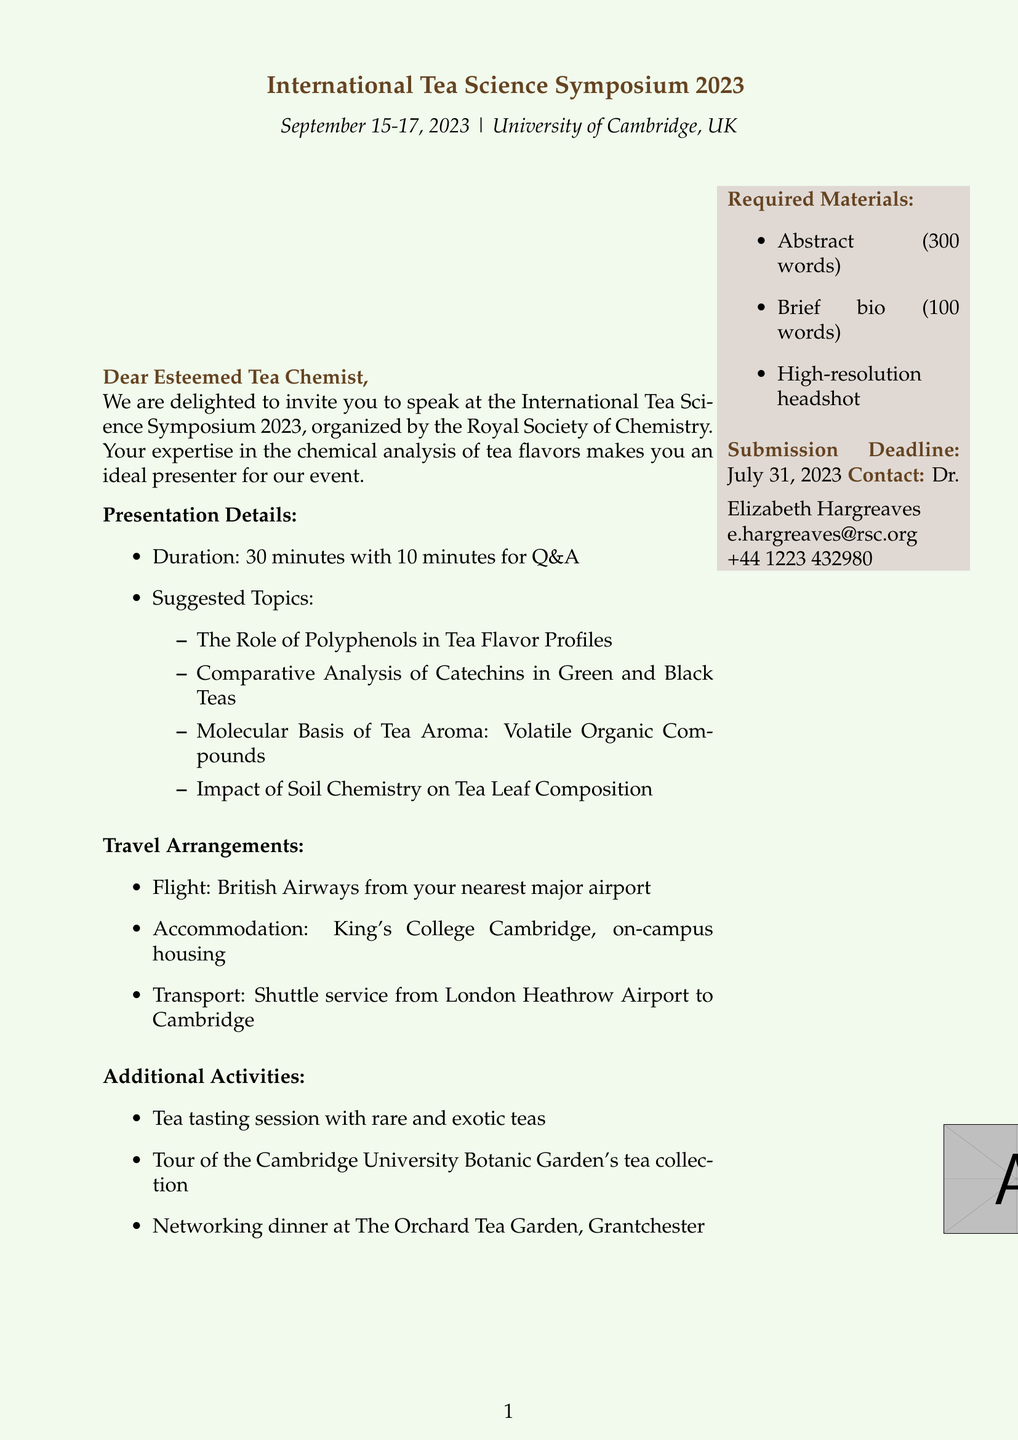What is the event name? The event name is explicitly mentioned in the document as part of the header.
Answer: International Tea Science Symposium 2023 When is the event scheduled? The event date is given clearly in the first few lines.
Answer: September 15-17, 2023 Who is organizing the symposium? The organizer's name is stated in the introduction of the document.
Answer: Royal Society of Chemistry What is the duration of each presentation? The presentation duration is specified under the presentation details section.
Answer: 30 minutes with 10 minutes for Q&A What transport arrangement is mentioned? The transport arrangement is outlined in the travel arrangements section of the document.
Answer: Shuttle service from London Heathrow Airport to Cambridge What materials are required for submission? The required materials are listed specifically towards the end of the document.
Answer: Abstract of your presentation, Brief bio, High-resolution headshot Who are the keynote speakers? The names of the keynote speakers are mentioned clearly in the document.
Answer: Dr. Yoshiko Kubo, Prof. Nikolai Kuhnert What additional activity involves tasting? The additional activities include a session that focuses on tasting specific items.
Answer: Tea tasting session with rare and exotic teas What is the submission deadline? The submission deadline is provided in its own section towards the end of the document.
Answer: July 31, 2023 